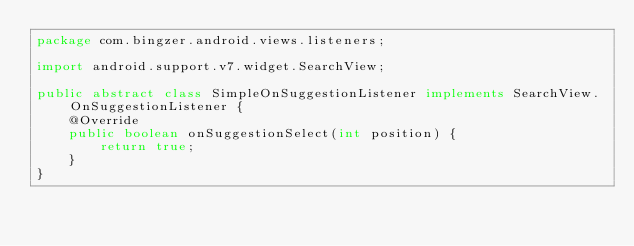Convert code to text. <code><loc_0><loc_0><loc_500><loc_500><_Java_>package com.bingzer.android.views.listeners;

import android.support.v7.widget.SearchView;

public abstract class SimpleOnSuggestionListener implements SearchView.OnSuggestionListener {
    @Override
    public boolean onSuggestionSelect(int position) {
        return true;
    }
}
</code> 